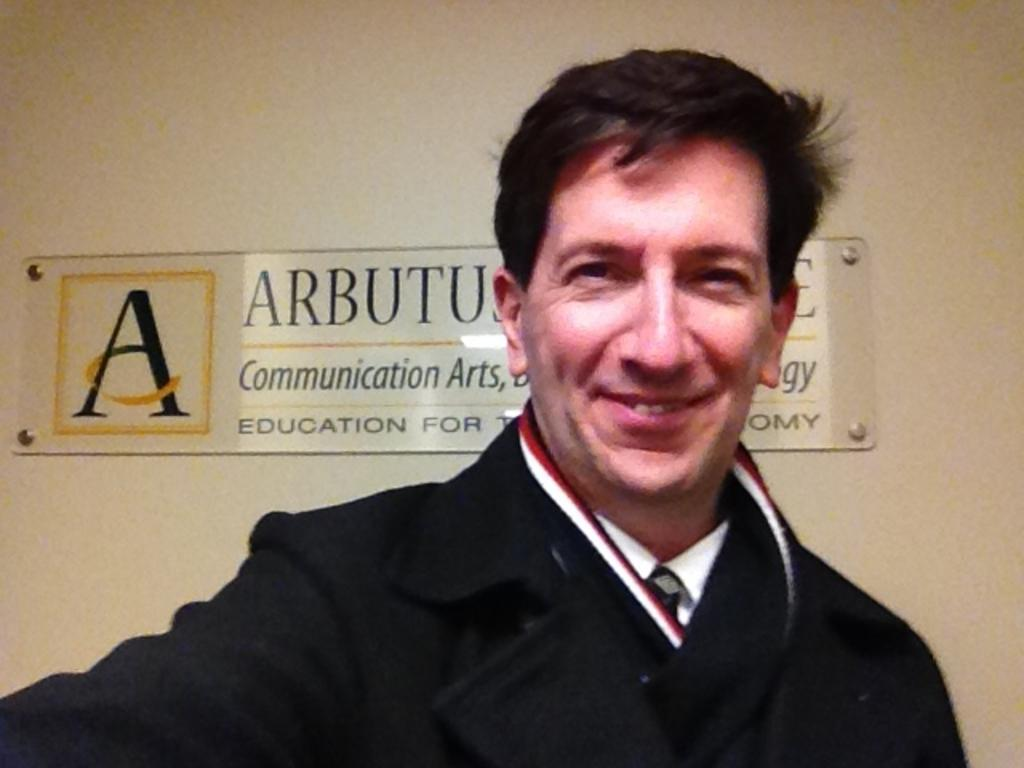What is the main subject of the image? There is a man standing in the image. Can you describe any additional elements in the background of the image? There is a name board on the wall in the background of the image. How many ducks are visible in the image? There are no ducks present in the image. What type of addition problem can be solved using the name board in the image? The name board in the image is not related to any addition problem, as it is simply a sign with a name on it. 